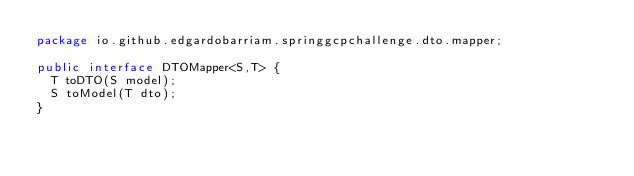Convert code to text. <code><loc_0><loc_0><loc_500><loc_500><_Java_>package io.github.edgardobarriam.springgcpchallenge.dto.mapper;

public interface DTOMapper<S,T> {
  T toDTO(S model);
  S toModel(T dto);
}
</code> 